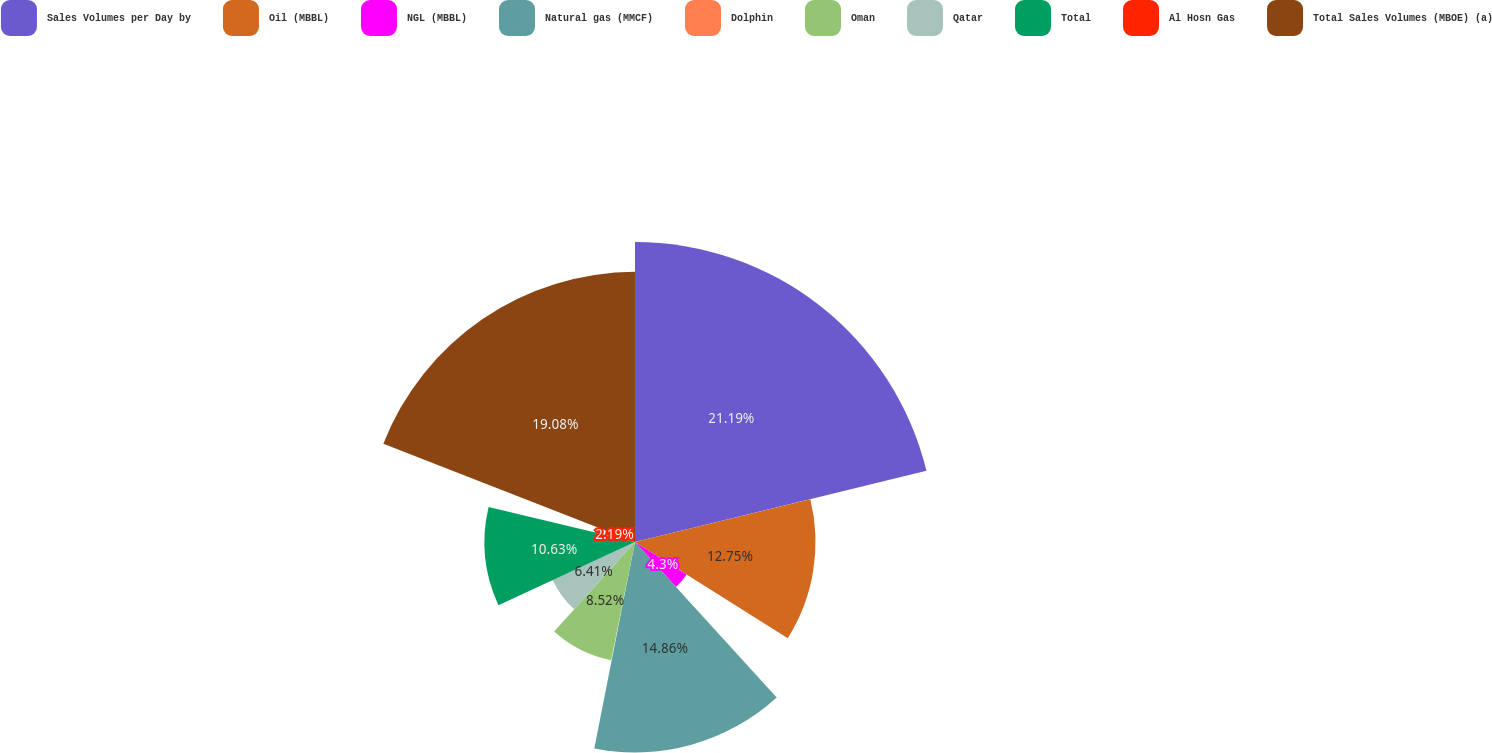Convert chart. <chart><loc_0><loc_0><loc_500><loc_500><pie_chart><fcel>Sales Volumes per Day by<fcel>Oil (MBBL)<fcel>NGL (MBBL)<fcel>Natural gas (MMCF)<fcel>Dolphin<fcel>Oman<fcel>Qatar<fcel>Total<fcel>Al Hosn Gas<fcel>Total Sales Volumes (MBOE) (a)<nl><fcel>21.19%<fcel>12.75%<fcel>4.3%<fcel>14.86%<fcel>0.07%<fcel>8.52%<fcel>6.41%<fcel>10.63%<fcel>2.19%<fcel>19.08%<nl></chart> 